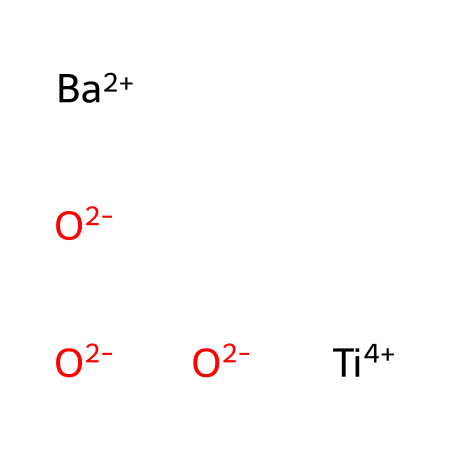What is the total charge of the compound? The compound consists of one barium ion with a charge of +2, one titanium ion with a charge of +4, and three oxide ions each with a charge of -2. To find the total charge, we can sum the charges: +2 (Ba) + +4 (Ti) + 3 * -2 (O) = +2 + 4 - 6 = 0. Therefore, the total charge is neutral.
Answer: neutral How many different types of atoms are present in this compound? The SMILES representation includes barium (Ba), titanium (Ti), and oxygen (O). Thus, there are three distinct types of atoms present in the compound: one barium atom, one titanium atom, and three oxygen atoms.
Answer: three What is the coordination number of the titanium atom in this structure? The titanium atom is surrounded by three oxygen atoms in the structure, where each oxygen provides a bond. The coordination number is therefore determined by the number of nearest neighbors around titanium, which in this case is three.
Answer: three What type of bonding is primarily present in this compound? The primary bonding in this compound is ionic. This is indicated by the presence of cations (Ba and Ti) and anions (O), where electrons are transferred from the metal atoms to the non-metal atoms, creating ionic bonds.
Answer: ionic What is the oxidation state of the barium atom in this compound? The barium atom in the compound bears a +2 charge, which indicates its oxidation state. The oxidation state is synonymous with the charge on the ion in ionic compounds, confirming that barium is in the +2 oxidation state.
Answer: +2 Which atom acts as the central atom in this compound? In the structure, titanium is typically considered the central atom as it has the highest positive oxidation state and coordinates with the surrounding oxygen atoms while also interacting with other cations, making it the central metal of the arrangement.
Answer: titanium 